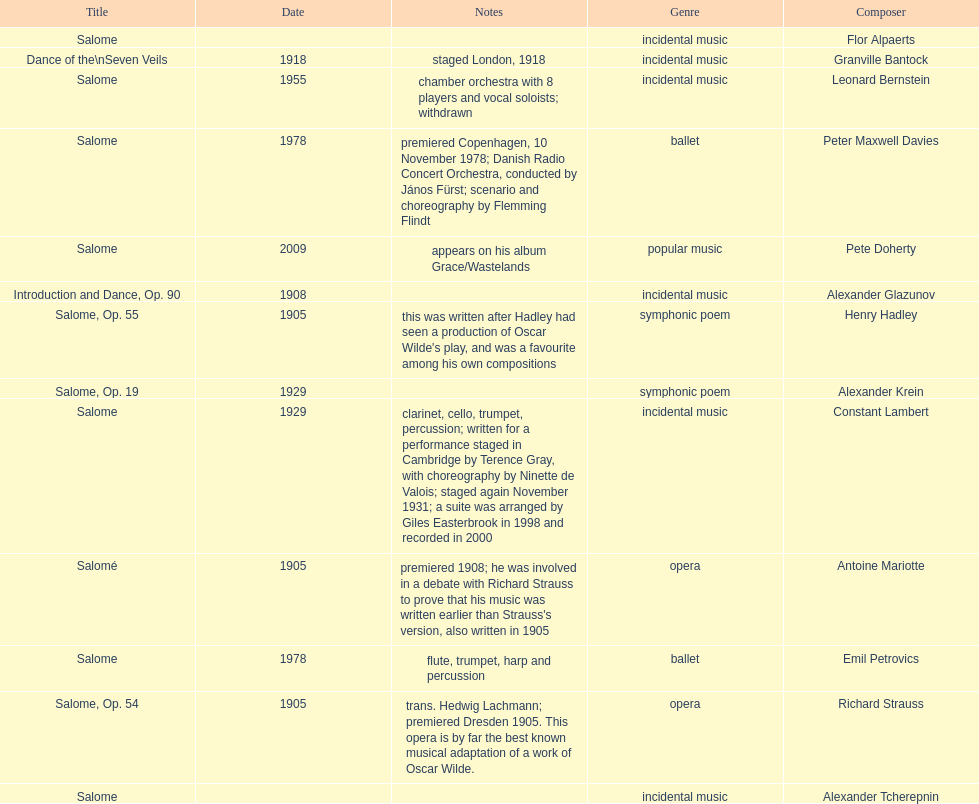Who is next on the list after alexander krein? Constant Lambert. 